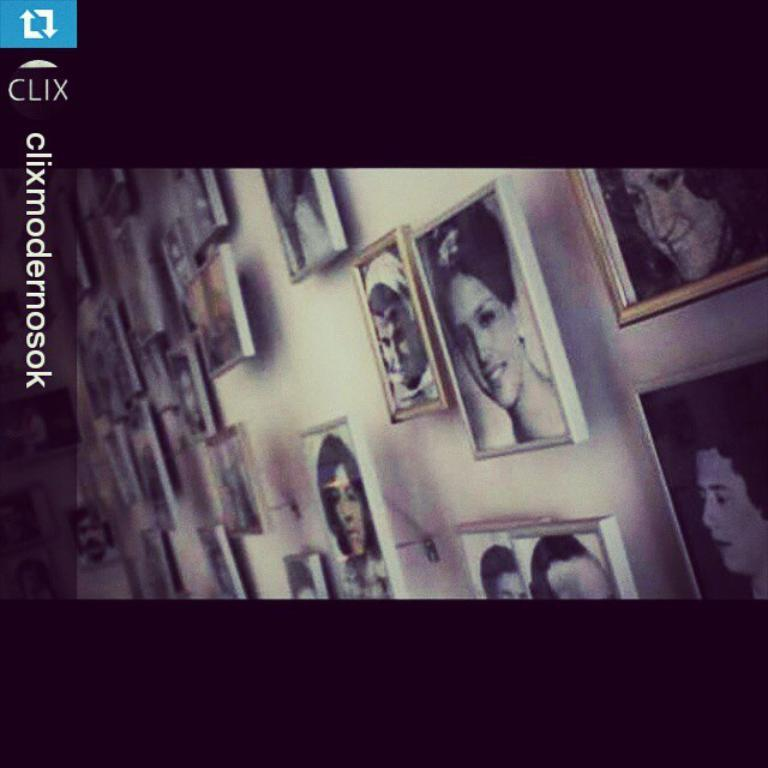What can be seen on the wall in the image? There are photo frames on the wall in the image. What else is present in the image besides the photo frames? There is some text in the image. Can you describe any additional features of the image? There is a watermark in the image. What type of winter clothing is being exchanged in the image? There is no winter clothing or exchange taking place in the image; it only features photo frames, text, and a watermark. What substance is being used to create the watermark in the image? The image does not provide information about the substance used to create the watermark. 